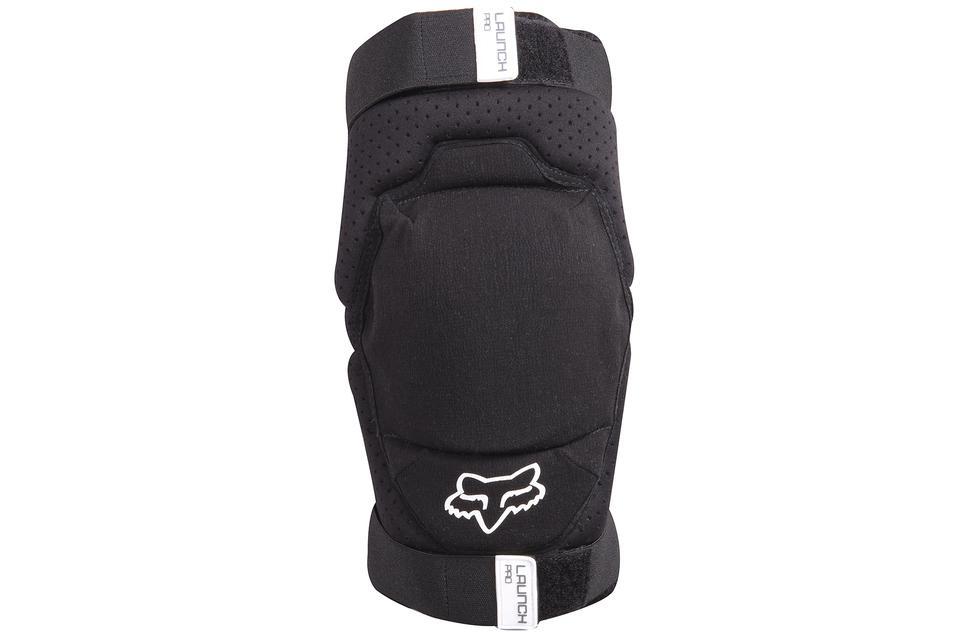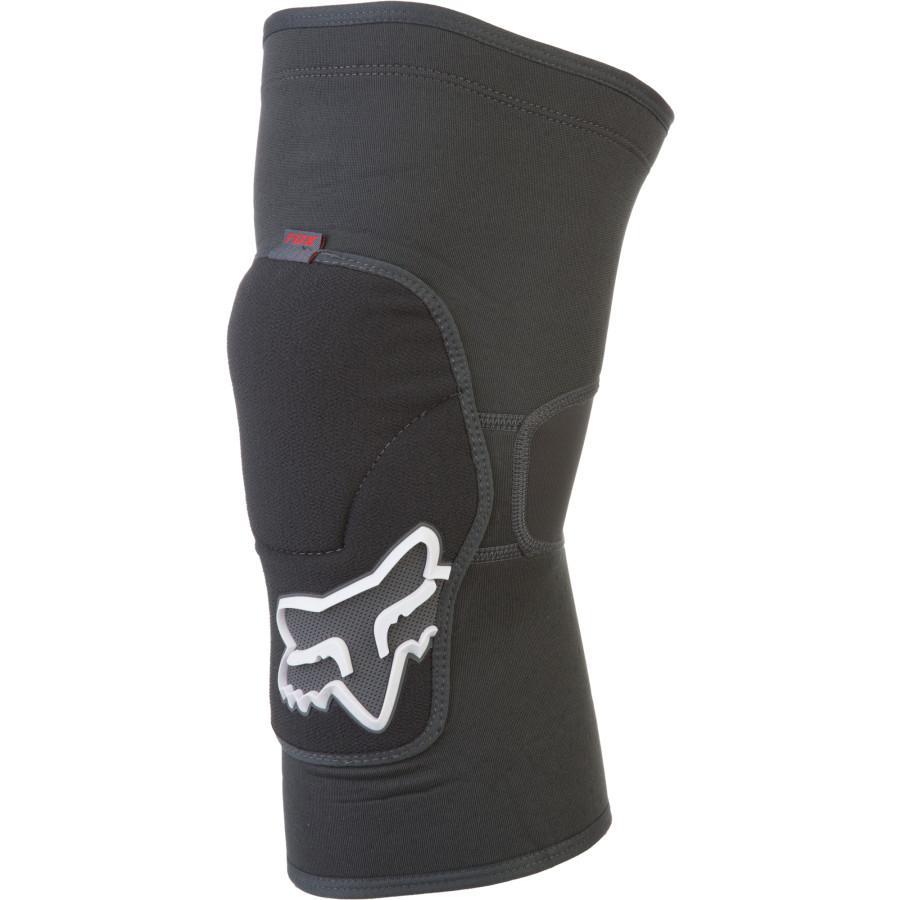The first image is the image on the left, the second image is the image on the right. Analyze the images presented: Is the assertion "both knee pads are black and shown unworn" valid? Answer yes or no. Yes. 